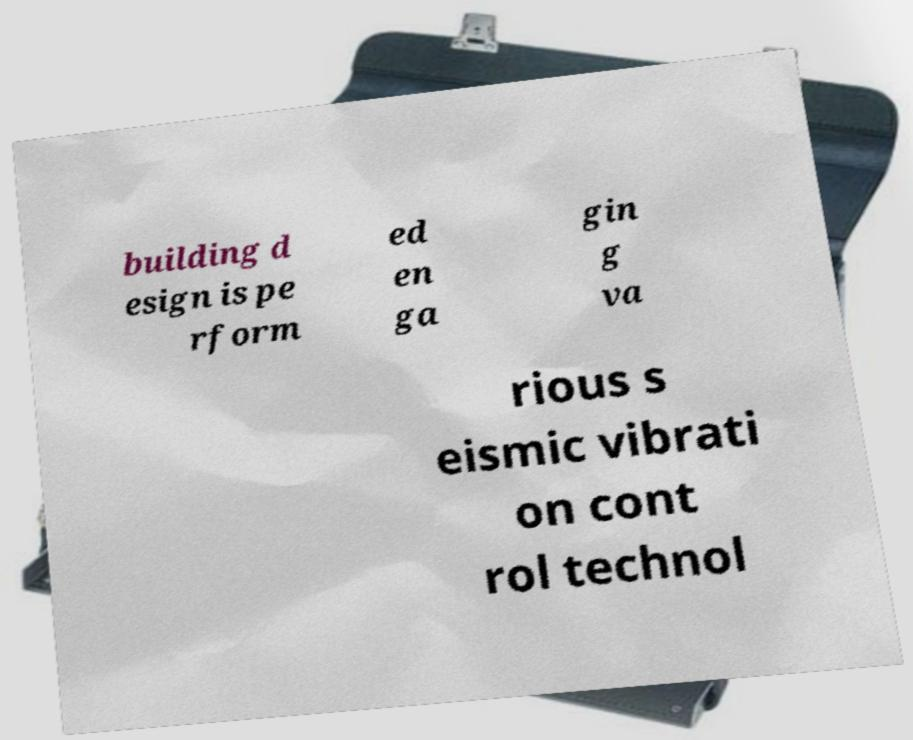Could you extract and type out the text from this image? building d esign is pe rform ed en ga gin g va rious s eismic vibrati on cont rol technol 